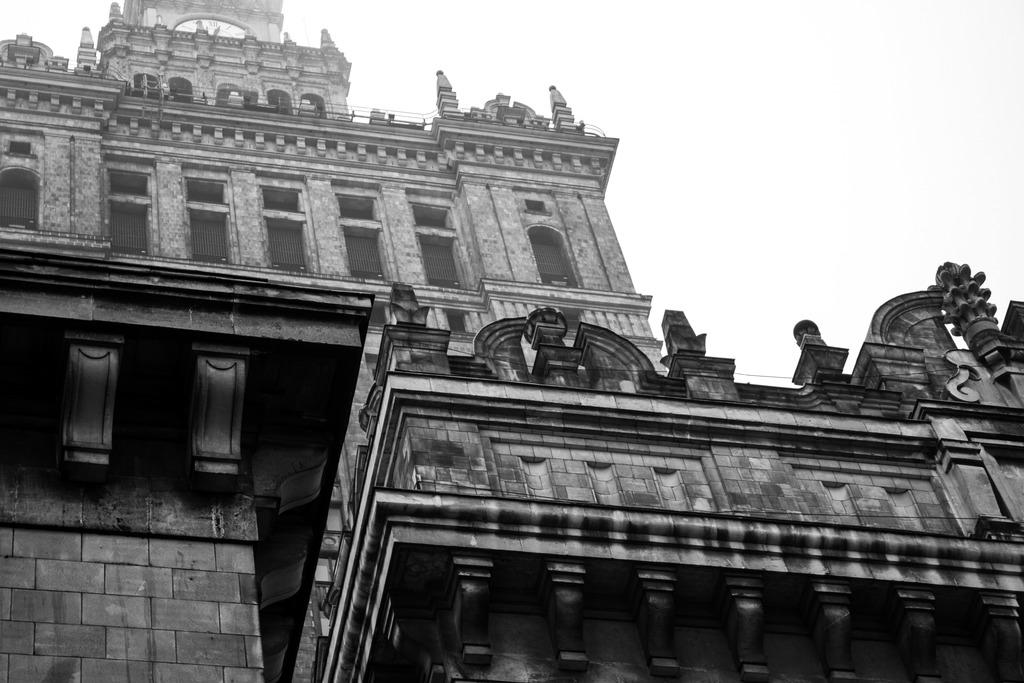What type of structure can be seen in the picture? There is a building in the picture. What part of the natural environment is visible in the picture? The sky is visible at the top of the picture. What type of bait is being used to catch fish in the picture? There is no fishing or bait present in the picture; it features a building and the sky. 